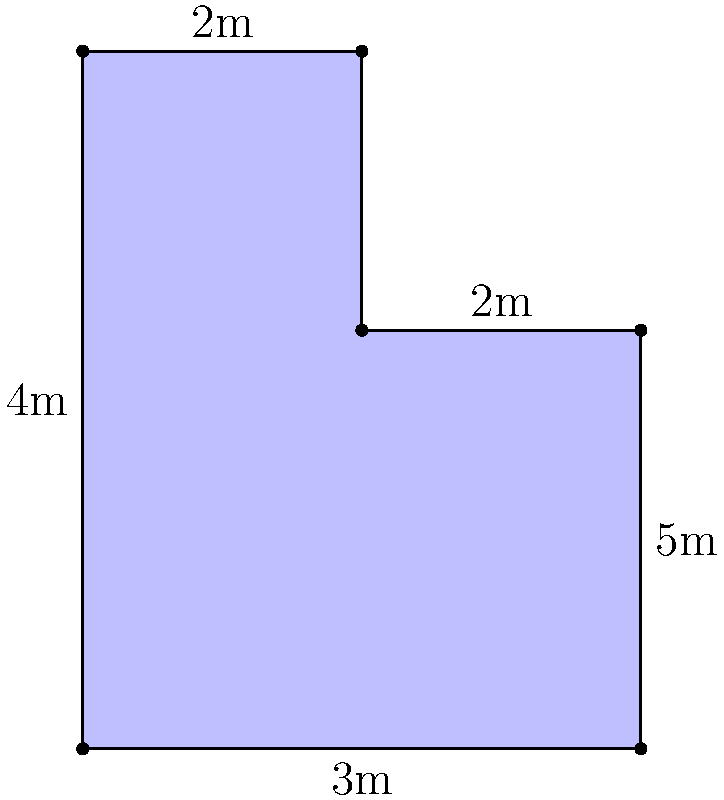As a Broadway actress collaborating with a retired set designer, you're working on a memoir that includes details about various stage props. One particular set piece has an unusual shape, as shown in the diagram. What is the total area of this oddly-shaped stage prop in square meters? To calculate the area of this oddly-shaped stage prop, we can break it down into simpler geometric shapes:

1. The shape can be divided into a rectangle and a rectangle with a "notch" taken out.

2. Let's calculate the area of the main rectangle:
   Area of main rectangle = $4\text{m} \times 3\text{m} = 12\text{m}^2$

3. Now, let's calculate the area of the upper part:
   - It's a $2\text{m} \times 2\text{m}$ square
   Area of upper square = $2\text{m} \times 2\text{m} = 4\text{m}^2$

4. The total area is the sum of these two parts:
   Total Area = $12\text{m}^2 + 4\text{m}^2 = 16\text{m}^2$

Therefore, the total area of the oddly-shaped stage prop is 16 square meters.
Answer: $16\text{m}^2$ 